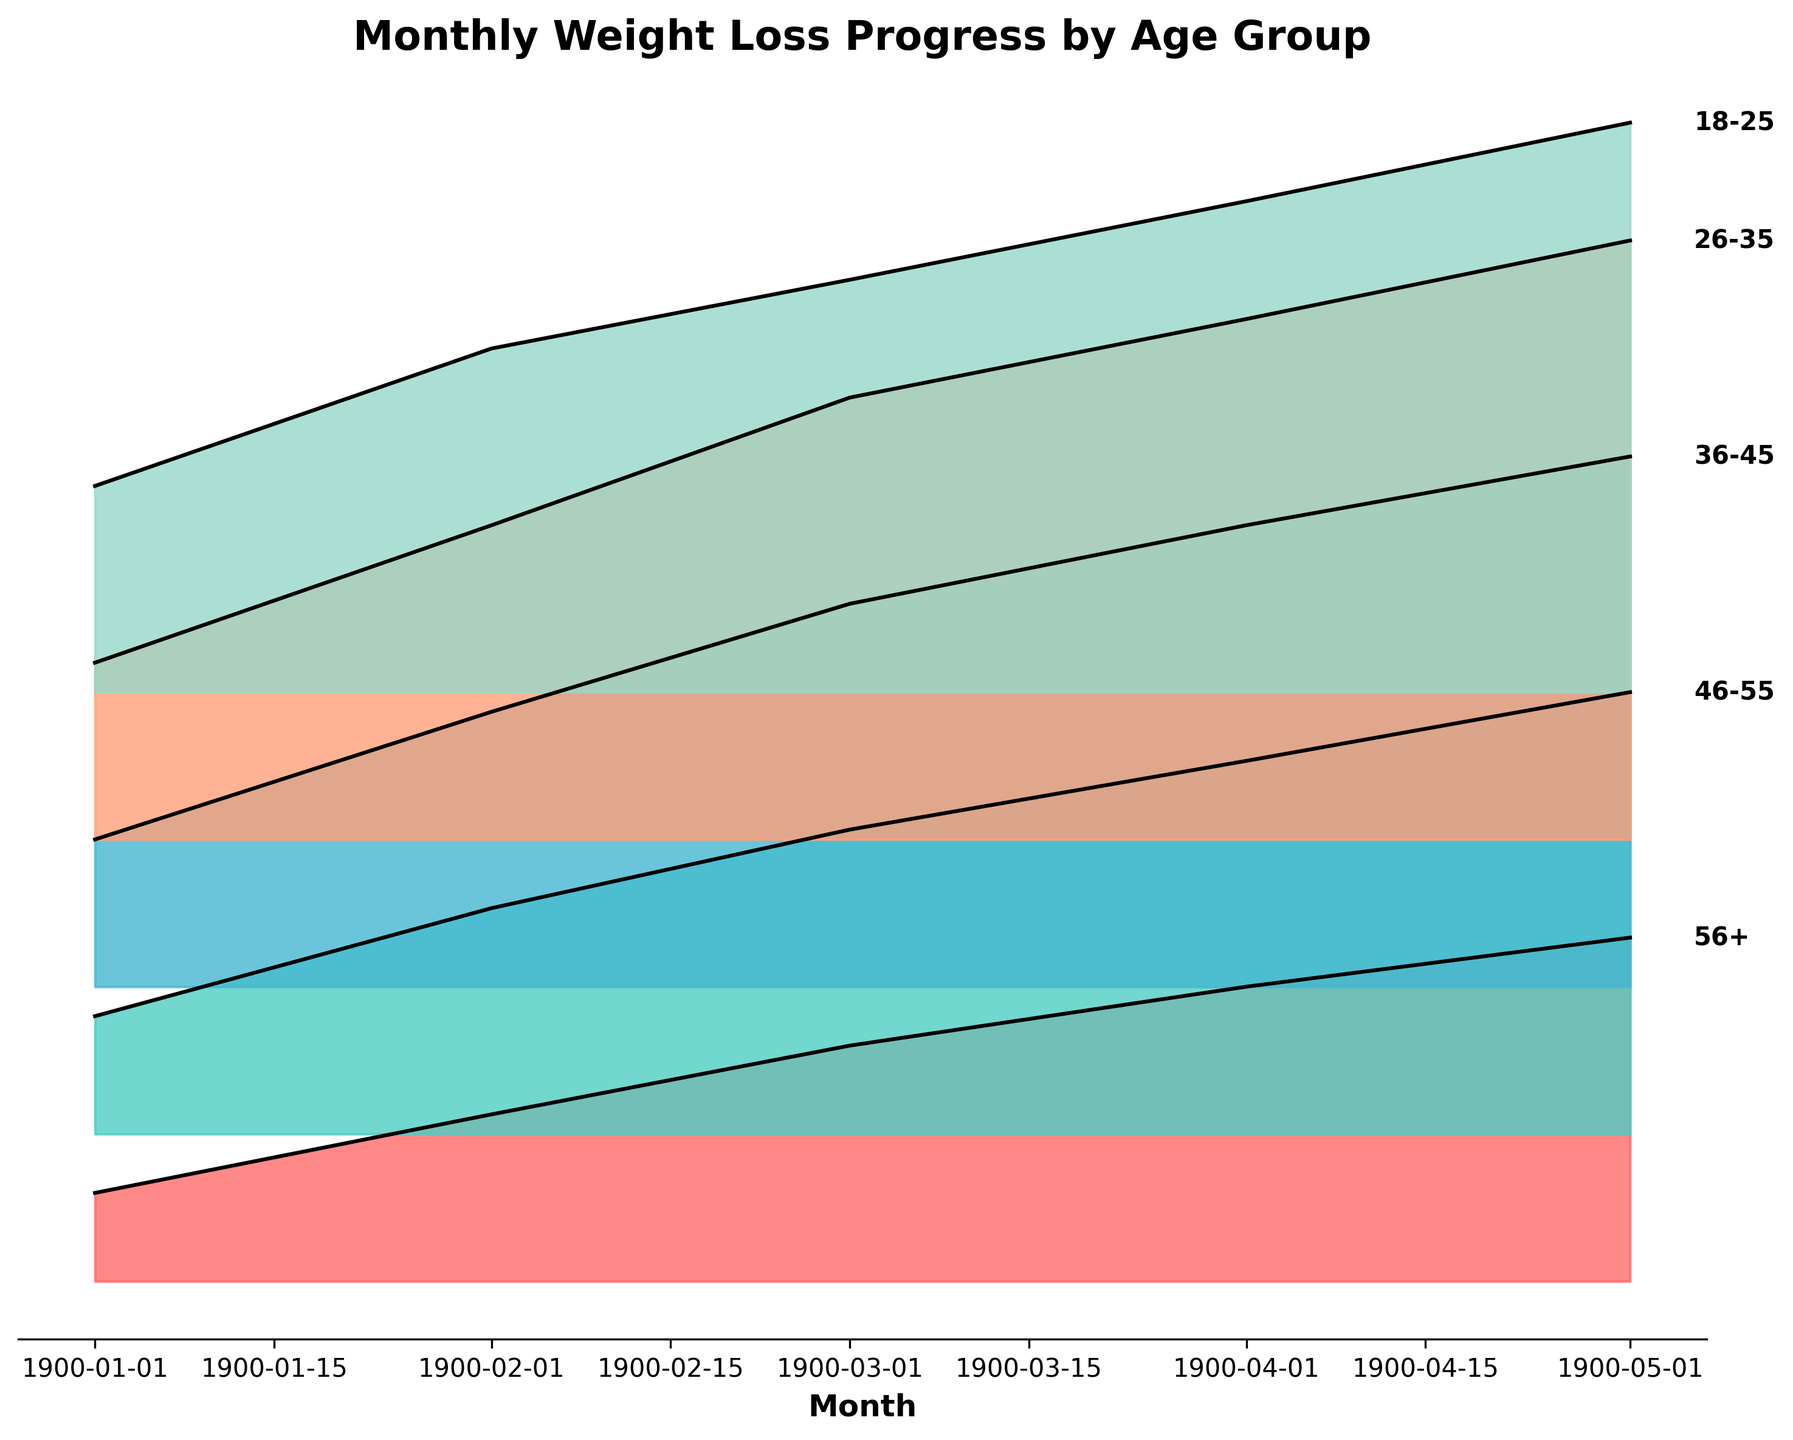What is the title of the plot? The title is usually found at the top of the figure, clearly indicating the main topic of the visual representation.
Answer: Monthly Weight Loss Progress by Age Group Which age group shows the most significant weight loss progress overall? By observing the height of the ridgeline bands, the tallest or most upward-moving group indicates the most significant weight loss. This can be benchmarked by comparing all groups.
Answer: 26-35 What month shows the highest weight loss for the 46-55 age group? Follow the 46-55 age group's plot line to find the peak month, which represents the highest value.
Answer: May How does the weight loss trend for the 18-25 age group change over the months? Look at the 18-25 age group's line from Jan to May, observing if it's generally going upward or downward.
Answer: Generally upward Compare the weight loss in January between the 36-45 and 56+ age groups: which group lost more weight? Locate both age groups on the vertical scale for January and compare their values. The higher value indicates more weight lost.
Answer: 36-45 What's the average weight loss of the 26-35 age group over the five months? Calculate the average by adding the weight loss values for each month and then dividing by the number of months (5).
Answer: 4.18 Which age group had the slowest initial weight loss in January? Identify all initial values (January) and find the smallest one among them.
Answer: 56+ In the plot, do younger or older age groups generally show greater weight loss by May? Compare the May values across all age groups, noting whether younger or older age groups have higher values.
Answer: Younger age groups What is the difference in weight loss between the 18-25 and 46-55 age groups in April? Subtract the April weight loss value of the 46-55 group from that of the 18-25 group to find the difference.
Answer: 1.2 Based on the plot, which month shows the steepest increase in weight loss for the 36-45 age group? Look for the month-to-month differences in the 36-45 group and identify the largest positive change.
Answer: February to March 